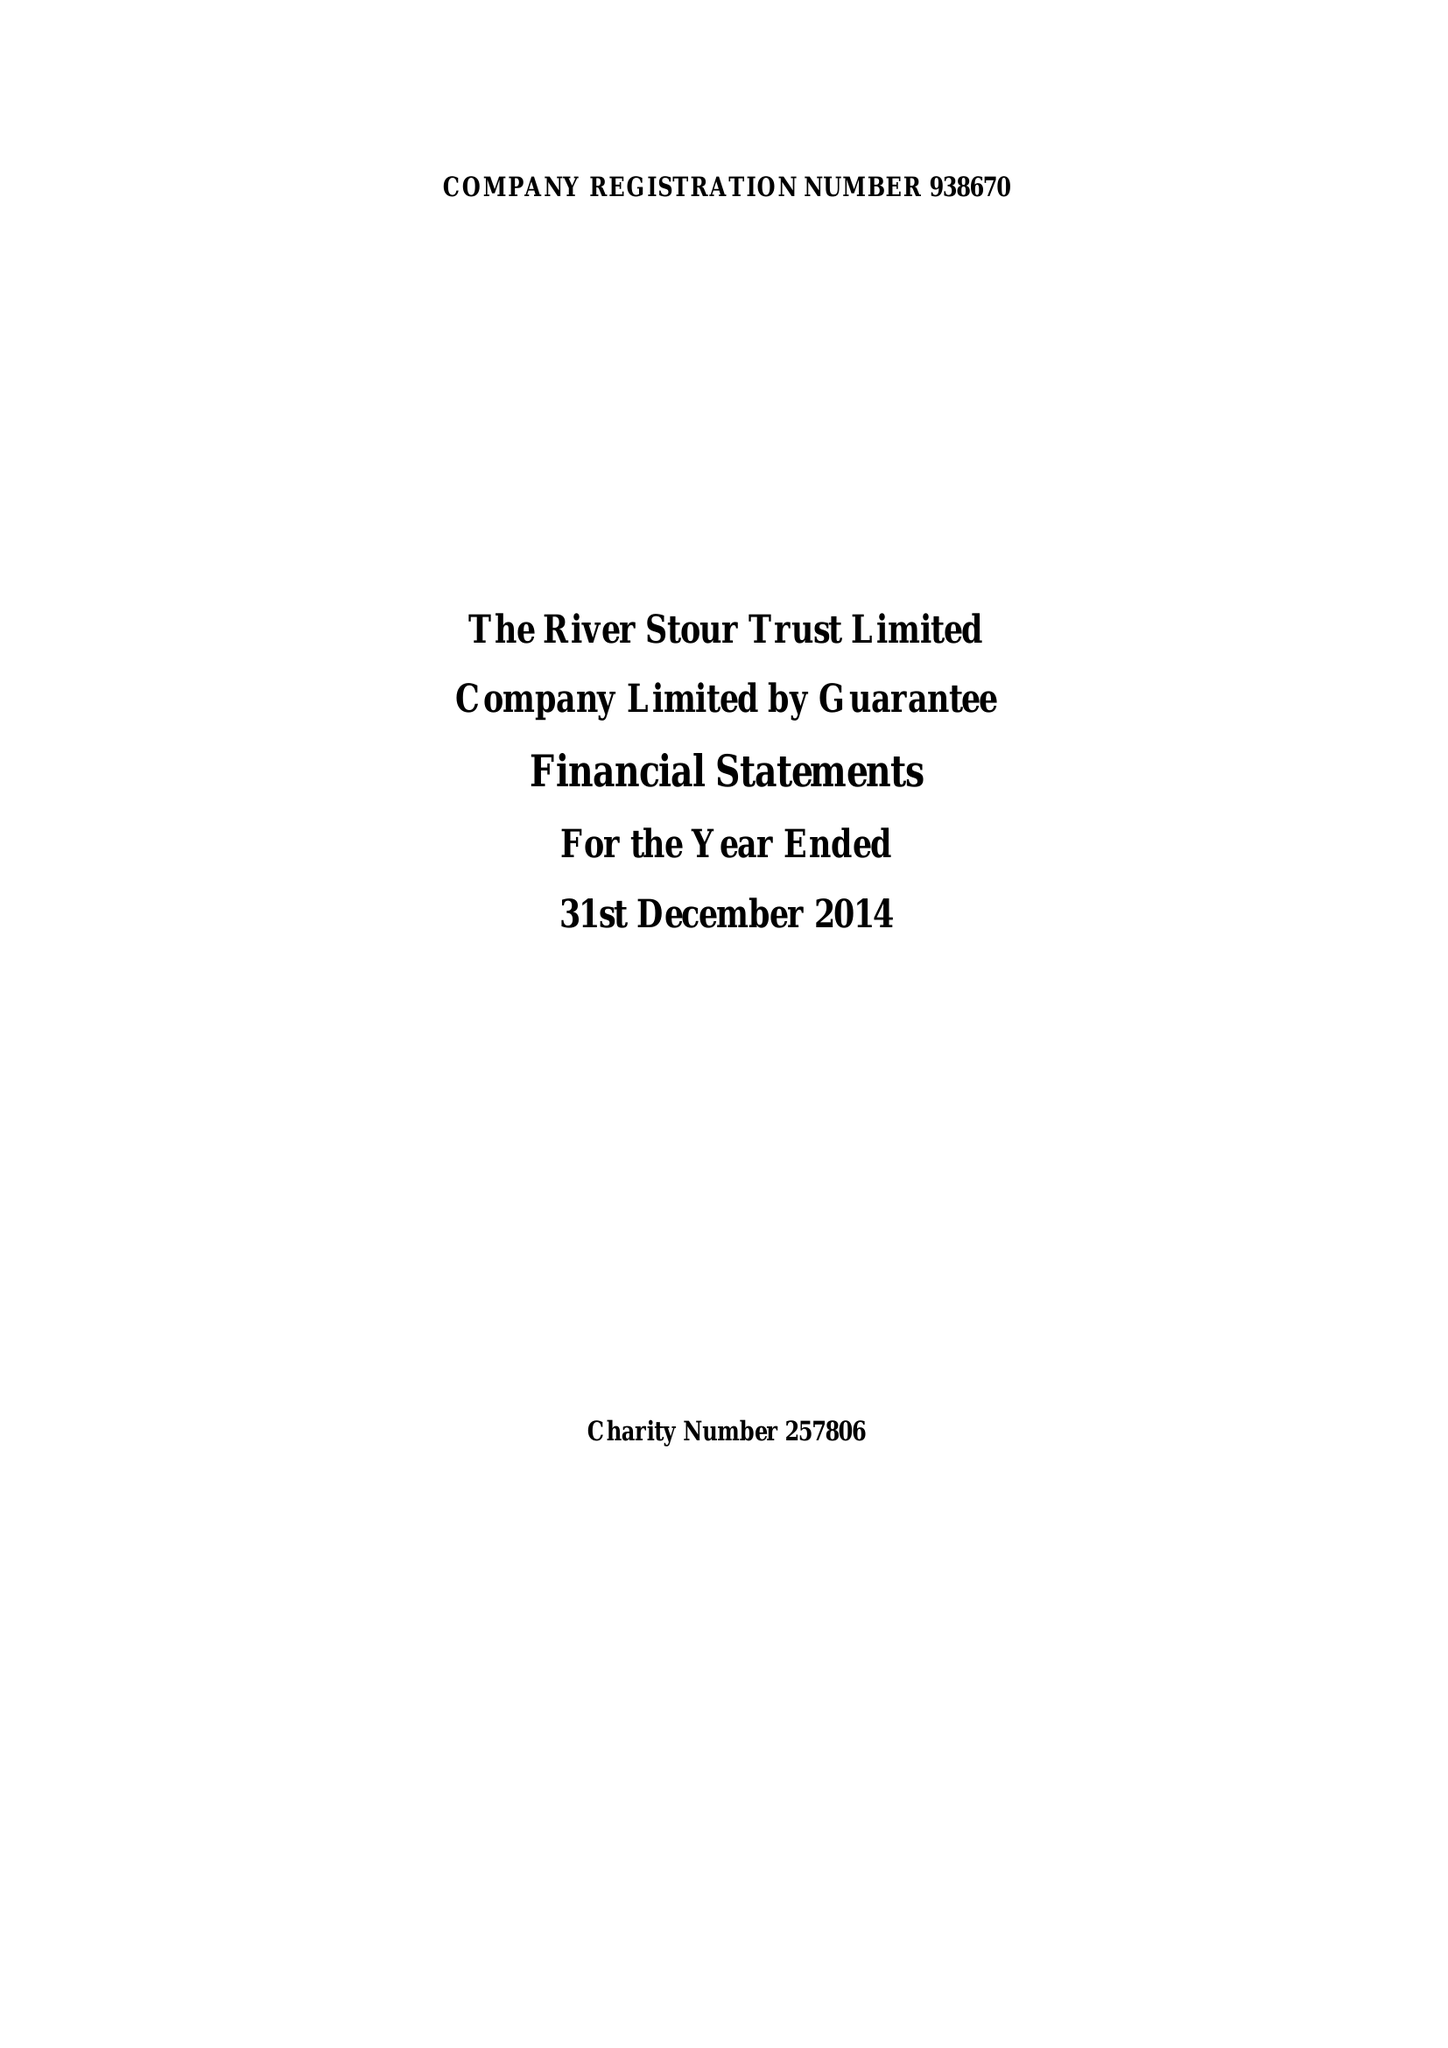What is the value for the spending_annually_in_british_pounds?
Answer the question using a single word or phrase. 91231.00 